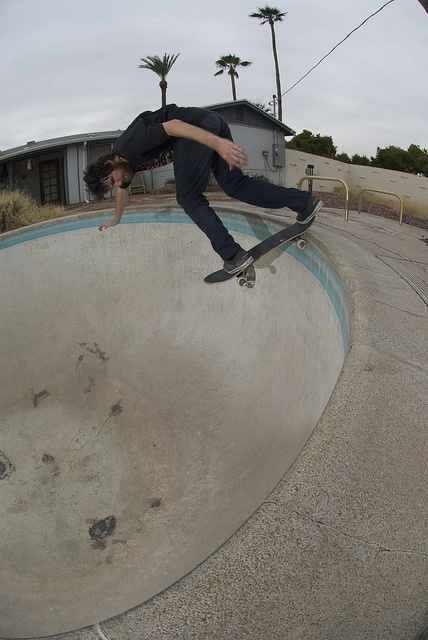Describe the objects in this image and their specific colors. I can see people in darkgray, black, and gray tones and skateboard in darkgray, black, and gray tones in this image. 